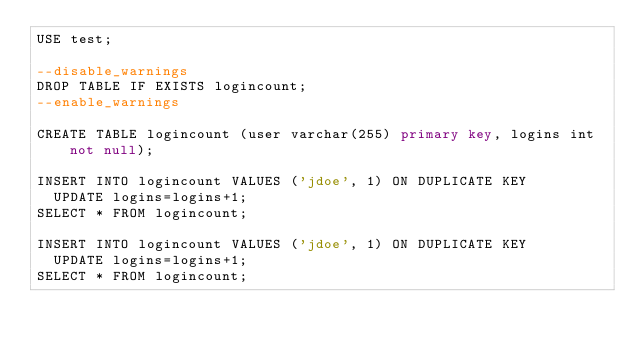Convert code to text. <code><loc_0><loc_0><loc_500><loc_500><_SQL_>USE test;

--disable_warnings
DROP TABLE IF EXISTS logincount;
--enable_warnings

CREATE TABLE logincount (user varchar(255) primary key, logins int not null);

INSERT INTO logincount VALUES ('jdoe', 1) ON DUPLICATE KEY
  UPDATE logins=logins+1;
SELECT * FROM logincount;

INSERT INTO logincount VALUES ('jdoe', 1) ON DUPLICATE KEY
  UPDATE logins=logins+1;
SELECT * FROM logincount;
</code> 